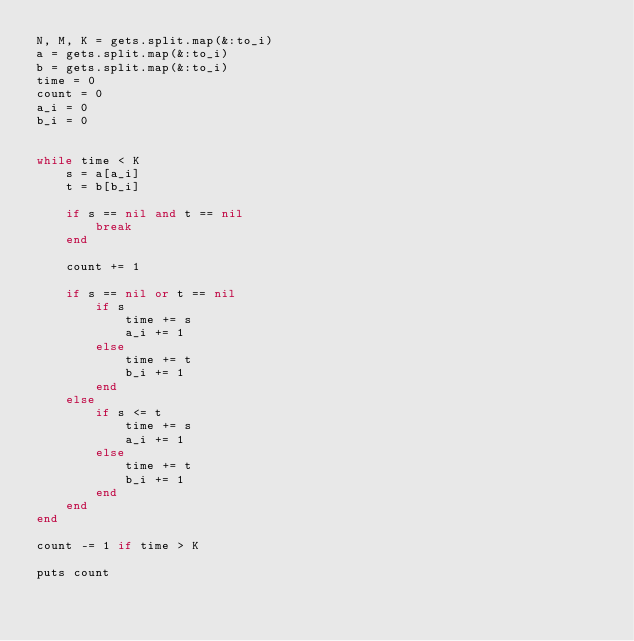Convert code to text. <code><loc_0><loc_0><loc_500><loc_500><_Ruby_>N, M, K = gets.split.map(&:to_i)
a = gets.split.map(&:to_i)
b = gets.split.map(&:to_i)
time = 0
count = 0
a_i = 0
b_i = 0


while time < K
    s = a[a_i]
    t = b[b_i]

    if s == nil and t == nil   
        break
    end

    count += 1

    if s == nil or t == nil
        if s
            time += s
            a_i += 1
        else
            time += t
            b_i += 1
        end
    else
        if s <= t
            time += s
            a_i += 1
        else
            time += t
            b_i += 1
        end 
    end
end

count -= 1 if time > K

puts count</code> 